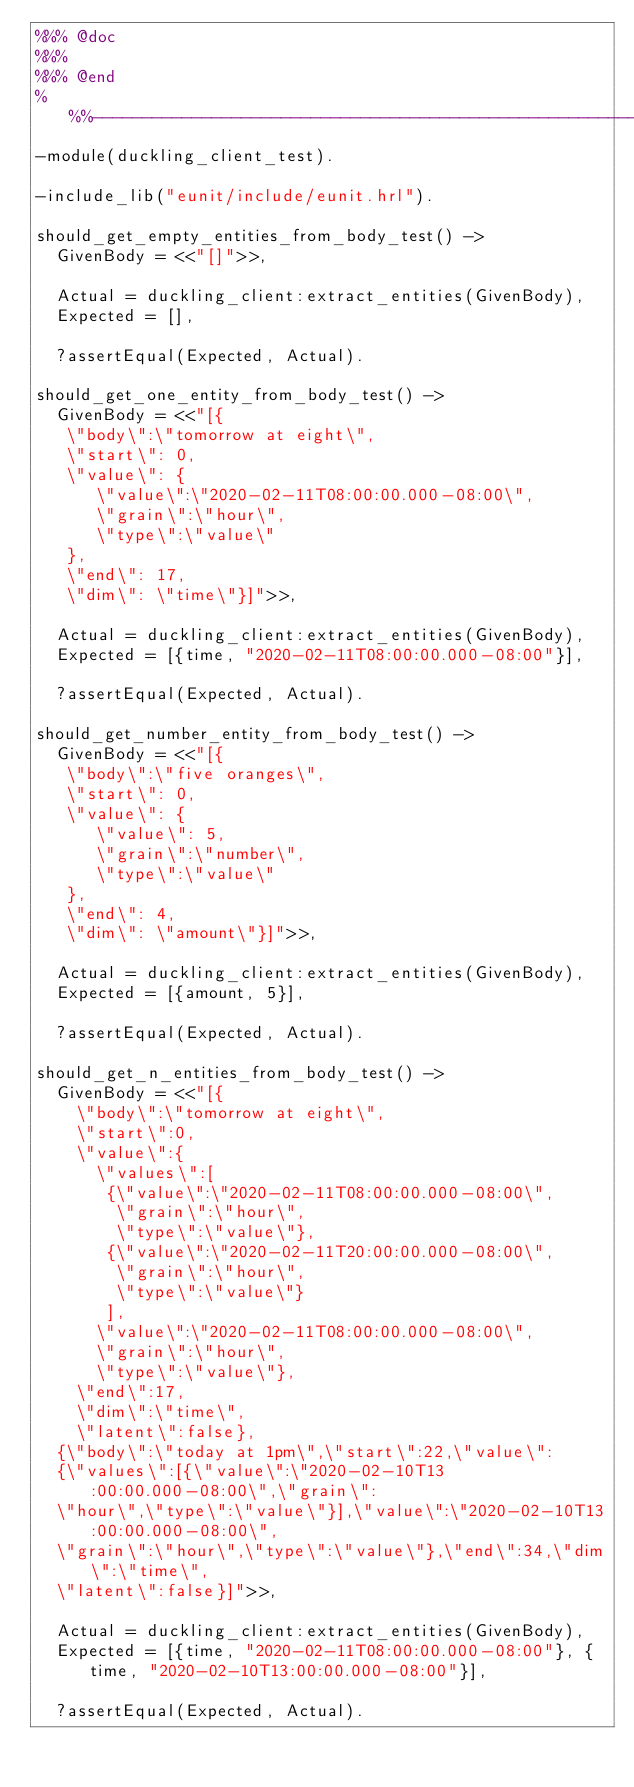Convert code to text. <code><loc_0><loc_0><loc_500><loc_500><_Erlang_>%%% @doc
%%%
%%% @end
%%%-------------------------------------------------------------------
-module(duckling_client_test).

-include_lib("eunit/include/eunit.hrl").

should_get_empty_entities_from_body_test() ->
  GivenBody = <<"[]">>,

  Actual = duckling_client:extract_entities(GivenBody),
  Expected = [],

  ?assertEqual(Expected, Actual).

should_get_one_entity_from_body_test() ->
  GivenBody = <<"[{
   \"body\":\"tomorrow at eight\",
   \"start\": 0,
   \"value\": {
      \"value\":\"2020-02-11T08:00:00.000-08:00\",
      \"grain\":\"hour\",
      \"type\":\"value\"
   },
   \"end\": 17,
   \"dim\": \"time\"}]">>,

  Actual = duckling_client:extract_entities(GivenBody),
  Expected = [{time, "2020-02-11T08:00:00.000-08:00"}],

  ?assertEqual(Expected, Actual).

should_get_number_entity_from_body_test() ->
  GivenBody = <<"[{
   \"body\":\"five oranges\",
   \"start\": 0,
   \"value\": {
      \"value\": 5,
      \"grain\":\"number\",
      \"type\":\"value\"
   },
   \"end\": 4,
   \"dim\": \"amount\"}]">>,

  Actual = duckling_client:extract_entities(GivenBody),
  Expected = [{amount, 5}],

  ?assertEqual(Expected, Actual).

should_get_n_entities_from_body_test() ->
  GivenBody = <<"[{
    \"body\":\"tomorrow at eight\",
    \"start\":0,
    \"value\":{
      \"values\":[
       {\"value\":\"2020-02-11T08:00:00.000-08:00\",
        \"grain\":\"hour\",
        \"type\":\"value\"},
       {\"value\":\"2020-02-11T20:00:00.000-08:00\",
        \"grain\":\"hour\",
        \"type\":\"value\"}
       ],
      \"value\":\"2020-02-11T08:00:00.000-08:00\",
      \"grain\":\"hour\",
      \"type\":\"value\"},
    \"end\":17,
    \"dim\":\"time\",
    \"latent\":false},
  {\"body\":\"today at 1pm\",\"start\":22,\"value\":
  {\"values\":[{\"value\":\"2020-02-10T13:00:00.000-08:00\",\"grain\":
  \"hour\",\"type\":\"value\"}],\"value\":\"2020-02-10T13:00:00.000-08:00\",
  \"grain\":\"hour\",\"type\":\"value\"},\"end\":34,\"dim\":\"time\",
  \"latent\":false}]">>,

  Actual = duckling_client:extract_entities(GivenBody),
  Expected = [{time, "2020-02-11T08:00:00.000-08:00"}, {time, "2020-02-10T13:00:00.000-08:00"}],

  ?assertEqual(Expected, Actual).
</code> 